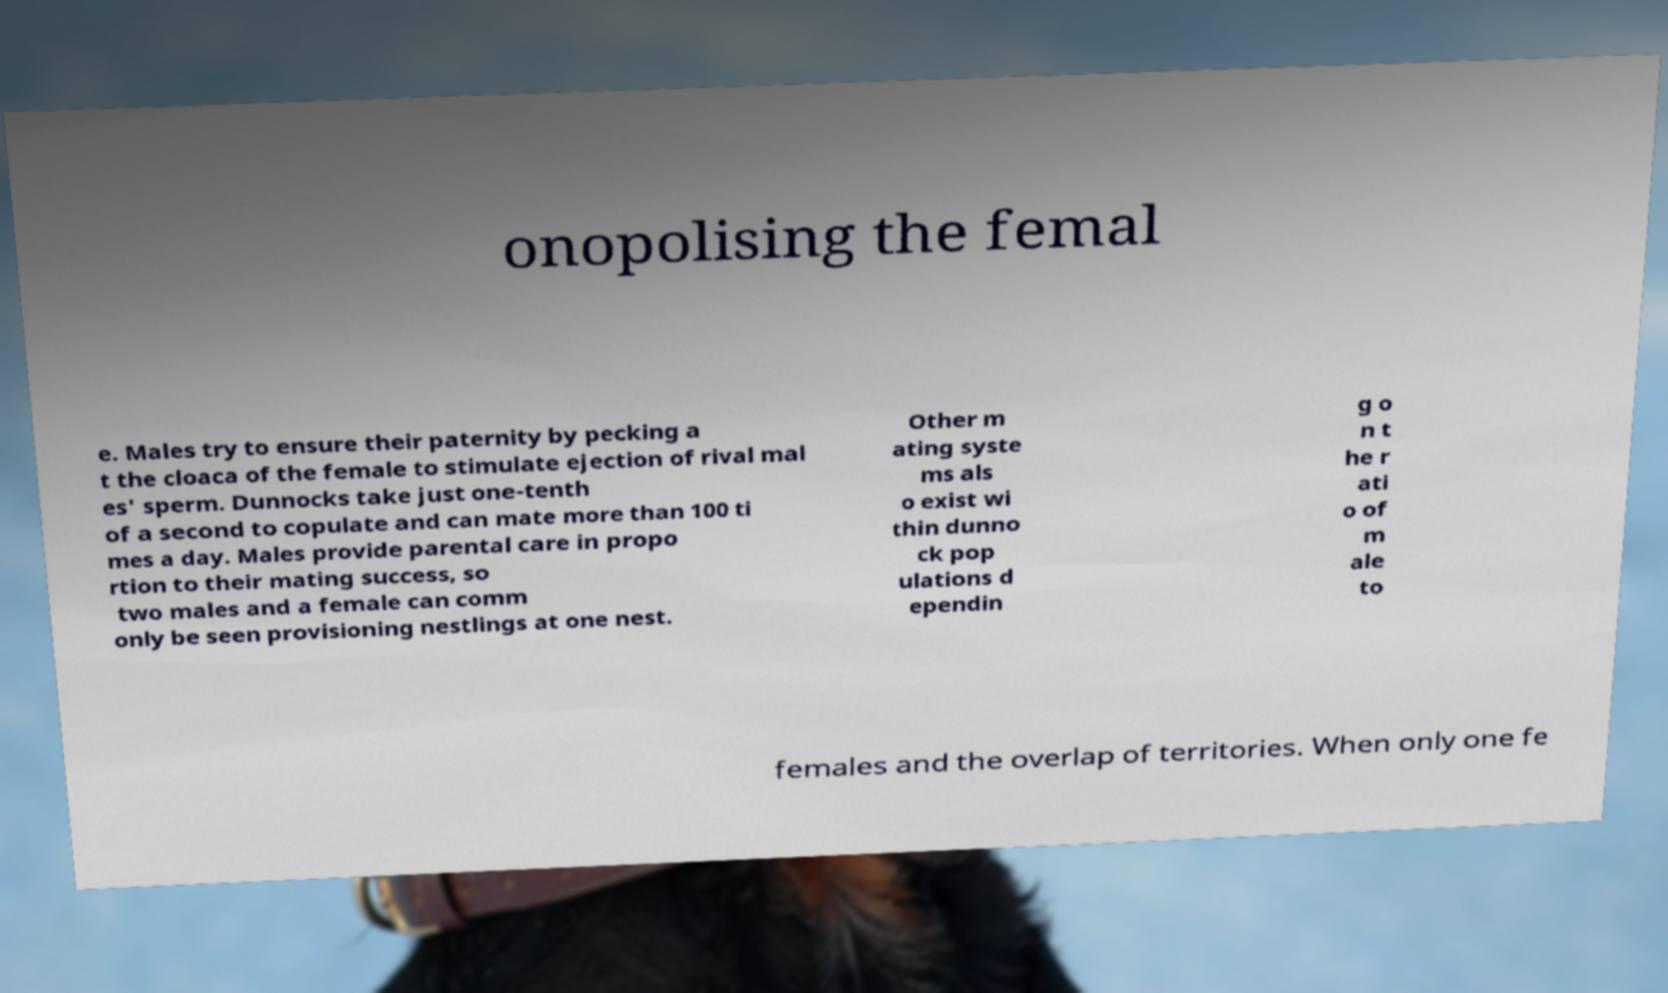Please read and relay the text visible in this image. What does it say? onopolising the femal e. Males try to ensure their paternity by pecking a t the cloaca of the female to stimulate ejection of rival mal es' sperm. Dunnocks take just one-tenth of a second to copulate and can mate more than 100 ti mes a day. Males provide parental care in propo rtion to their mating success, so two males and a female can comm only be seen provisioning nestlings at one nest. Other m ating syste ms als o exist wi thin dunno ck pop ulations d ependin g o n t he r ati o of m ale to females and the overlap of territories. When only one fe 